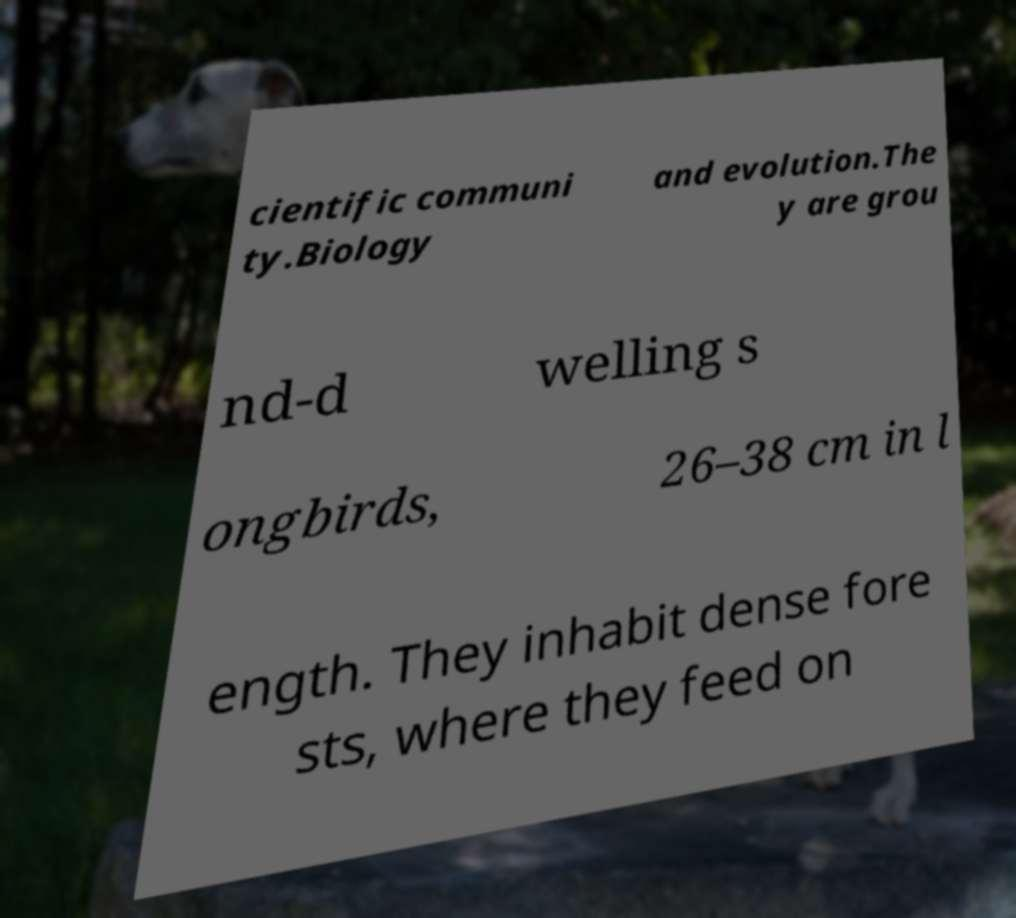Can you read and provide the text displayed in the image?This photo seems to have some interesting text. Can you extract and type it out for me? cientific communi ty.Biology and evolution.The y are grou nd-d welling s ongbirds, 26–38 cm in l ength. They inhabit dense fore sts, where they feed on 